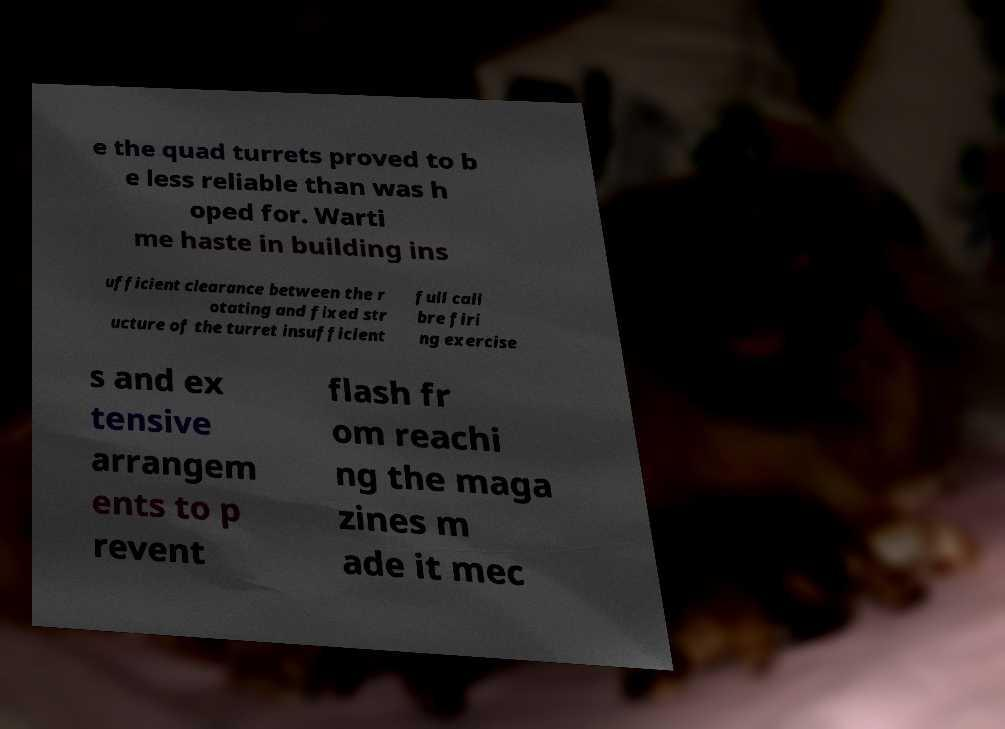Please read and relay the text visible in this image. What does it say? e the quad turrets proved to b e less reliable than was h oped for. Warti me haste in building ins ufficient clearance between the r otating and fixed str ucture of the turret insufficient full cali bre firi ng exercise s and ex tensive arrangem ents to p revent flash fr om reachi ng the maga zines m ade it mec 